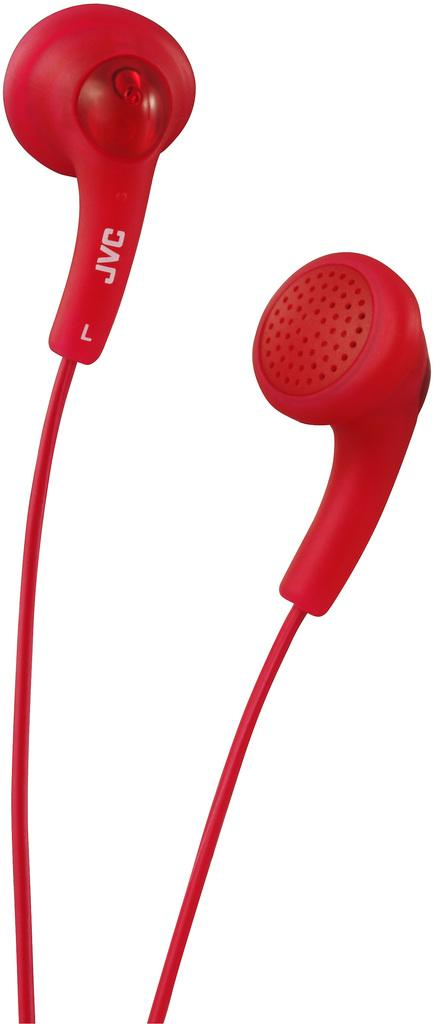What type of audio accessory is present in the image? There are red color earphones in the image. What color are the earphones? The earphones are red. What is the color of the background in the image? The background of the image is white. What type of fruit is being used as a seat in the image? There is no fruit or seat present in the image; it only features red color earphones against a white background. 